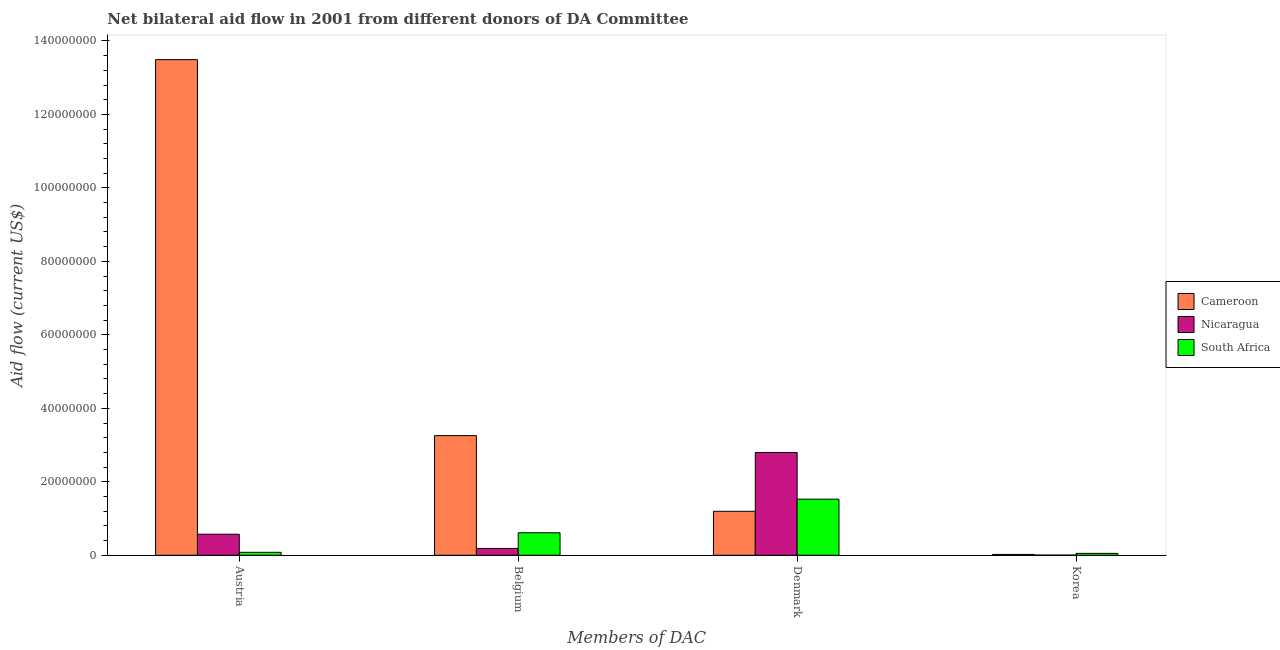How many groups of bars are there?
Make the answer very short. 4. Are the number of bars per tick equal to the number of legend labels?
Your response must be concise. Yes. How many bars are there on the 3rd tick from the left?
Offer a terse response. 3. What is the amount of aid given by austria in South Africa?
Keep it short and to the point. 8.00e+05. Across all countries, what is the maximum amount of aid given by korea?
Your answer should be compact. 5.10e+05. Across all countries, what is the minimum amount of aid given by korea?
Keep it short and to the point. 4.00e+04. In which country was the amount of aid given by korea maximum?
Provide a short and direct response. South Africa. In which country was the amount of aid given by austria minimum?
Make the answer very short. South Africa. What is the total amount of aid given by denmark in the graph?
Offer a very short reply. 5.52e+07. What is the difference between the amount of aid given by korea in Nicaragua and that in South Africa?
Ensure brevity in your answer.  -4.70e+05. What is the difference between the amount of aid given by korea in Nicaragua and the amount of aid given by austria in Cameroon?
Your response must be concise. -1.35e+08. What is the average amount of aid given by belgium per country?
Give a very brief answer. 1.35e+07. What is the difference between the amount of aid given by austria and amount of aid given by denmark in South Africa?
Make the answer very short. -1.45e+07. In how many countries, is the amount of aid given by austria greater than 40000000 US$?
Provide a short and direct response. 1. What is the ratio of the amount of aid given by korea in Cameroon to that in South Africa?
Keep it short and to the point. 0.45. Is the amount of aid given by belgium in South Africa less than that in Nicaragua?
Your response must be concise. No. What is the difference between the highest and the lowest amount of aid given by korea?
Your answer should be very brief. 4.70e+05. What does the 2nd bar from the left in Belgium represents?
Provide a short and direct response. Nicaragua. What does the 2nd bar from the right in Belgium represents?
Provide a succinct answer. Nicaragua. Is it the case that in every country, the sum of the amount of aid given by austria and amount of aid given by belgium is greater than the amount of aid given by denmark?
Make the answer very short. No. How many bars are there?
Your answer should be compact. 12. How many countries are there in the graph?
Your response must be concise. 3. What is the difference between two consecutive major ticks on the Y-axis?
Give a very brief answer. 2.00e+07. Does the graph contain any zero values?
Make the answer very short. No. What is the title of the graph?
Keep it short and to the point. Net bilateral aid flow in 2001 from different donors of DA Committee. Does "Brazil" appear as one of the legend labels in the graph?
Make the answer very short. No. What is the label or title of the X-axis?
Offer a very short reply. Members of DAC. What is the label or title of the Y-axis?
Offer a very short reply. Aid flow (current US$). What is the Aid flow (current US$) in Cameroon in Austria?
Your answer should be very brief. 1.35e+08. What is the Aid flow (current US$) in Nicaragua in Austria?
Provide a succinct answer. 5.73e+06. What is the Aid flow (current US$) in Cameroon in Belgium?
Ensure brevity in your answer.  3.26e+07. What is the Aid flow (current US$) in Nicaragua in Belgium?
Offer a terse response. 1.86e+06. What is the Aid flow (current US$) in South Africa in Belgium?
Offer a very short reply. 6.12e+06. What is the Aid flow (current US$) of Cameroon in Denmark?
Provide a succinct answer. 1.20e+07. What is the Aid flow (current US$) of Nicaragua in Denmark?
Ensure brevity in your answer.  2.80e+07. What is the Aid flow (current US$) in South Africa in Denmark?
Offer a very short reply. 1.53e+07. What is the Aid flow (current US$) of Cameroon in Korea?
Offer a very short reply. 2.30e+05. What is the Aid flow (current US$) of Nicaragua in Korea?
Give a very brief answer. 4.00e+04. What is the Aid flow (current US$) of South Africa in Korea?
Give a very brief answer. 5.10e+05. Across all Members of DAC, what is the maximum Aid flow (current US$) of Cameroon?
Provide a short and direct response. 1.35e+08. Across all Members of DAC, what is the maximum Aid flow (current US$) in Nicaragua?
Provide a succinct answer. 2.80e+07. Across all Members of DAC, what is the maximum Aid flow (current US$) of South Africa?
Your answer should be very brief. 1.53e+07. Across all Members of DAC, what is the minimum Aid flow (current US$) of Cameroon?
Your response must be concise. 2.30e+05. Across all Members of DAC, what is the minimum Aid flow (current US$) of South Africa?
Make the answer very short. 5.10e+05. What is the total Aid flow (current US$) of Cameroon in the graph?
Make the answer very short. 1.80e+08. What is the total Aid flow (current US$) of Nicaragua in the graph?
Keep it short and to the point. 3.56e+07. What is the total Aid flow (current US$) of South Africa in the graph?
Offer a very short reply. 2.27e+07. What is the difference between the Aid flow (current US$) in Cameroon in Austria and that in Belgium?
Give a very brief answer. 1.02e+08. What is the difference between the Aid flow (current US$) in Nicaragua in Austria and that in Belgium?
Provide a succinct answer. 3.87e+06. What is the difference between the Aid flow (current US$) in South Africa in Austria and that in Belgium?
Give a very brief answer. -5.32e+06. What is the difference between the Aid flow (current US$) in Cameroon in Austria and that in Denmark?
Provide a short and direct response. 1.23e+08. What is the difference between the Aid flow (current US$) in Nicaragua in Austria and that in Denmark?
Your answer should be compact. -2.22e+07. What is the difference between the Aid flow (current US$) of South Africa in Austria and that in Denmark?
Ensure brevity in your answer.  -1.45e+07. What is the difference between the Aid flow (current US$) in Cameroon in Austria and that in Korea?
Make the answer very short. 1.35e+08. What is the difference between the Aid flow (current US$) of Nicaragua in Austria and that in Korea?
Give a very brief answer. 5.69e+06. What is the difference between the Aid flow (current US$) of South Africa in Austria and that in Korea?
Make the answer very short. 2.90e+05. What is the difference between the Aid flow (current US$) of Cameroon in Belgium and that in Denmark?
Ensure brevity in your answer.  2.06e+07. What is the difference between the Aid flow (current US$) of Nicaragua in Belgium and that in Denmark?
Your answer should be compact. -2.61e+07. What is the difference between the Aid flow (current US$) in South Africa in Belgium and that in Denmark?
Your response must be concise. -9.15e+06. What is the difference between the Aid flow (current US$) in Cameroon in Belgium and that in Korea?
Your response must be concise. 3.23e+07. What is the difference between the Aid flow (current US$) in Nicaragua in Belgium and that in Korea?
Your answer should be very brief. 1.82e+06. What is the difference between the Aid flow (current US$) of South Africa in Belgium and that in Korea?
Your response must be concise. 5.61e+06. What is the difference between the Aid flow (current US$) of Cameroon in Denmark and that in Korea?
Your answer should be very brief. 1.17e+07. What is the difference between the Aid flow (current US$) of Nicaragua in Denmark and that in Korea?
Your answer should be very brief. 2.79e+07. What is the difference between the Aid flow (current US$) in South Africa in Denmark and that in Korea?
Provide a succinct answer. 1.48e+07. What is the difference between the Aid flow (current US$) in Cameroon in Austria and the Aid flow (current US$) in Nicaragua in Belgium?
Provide a succinct answer. 1.33e+08. What is the difference between the Aid flow (current US$) in Cameroon in Austria and the Aid flow (current US$) in South Africa in Belgium?
Your answer should be compact. 1.29e+08. What is the difference between the Aid flow (current US$) in Nicaragua in Austria and the Aid flow (current US$) in South Africa in Belgium?
Your answer should be very brief. -3.90e+05. What is the difference between the Aid flow (current US$) in Cameroon in Austria and the Aid flow (current US$) in Nicaragua in Denmark?
Offer a terse response. 1.07e+08. What is the difference between the Aid flow (current US$) in Cameroon in Austria and the Aid flow (current US$) in South Africa in Denmark?
Provide a short and direct response. 1.20e+08. What is the difference between the Aid flow (current US$) in Nicaragua in Austria and the Aid flow (current US$) in South Africa in Denmark?
Make the answer very short. -9.54e+06. What is the difference between the Aid flow (current US$) of Cameroon in Austria and the Aid flow (current US$) of Nicaragua in Korea?
Keep it short and to the point. 1.35e+08. What is the difference between the Aid flow (current US$) of Cameroon in Austria and the Aid flow (current US$) of South Africa in Korea?
Provide a succinct answer. 1.34e+08. What is the difference between the Aid flow (current US$) of Nicaragua in Austria and the Aid flow (current US$) of South Africa in Korea?
Your answer should be very brief. 5.22e+06. What is the difference between the Aid flow (current US$) in Cameroon in Belgium and the Aid flow (current US$) in Nicaragua in Denmark?
Provide a short and direct response. 4.60e+06. What is the difference between the Aid flow (current US$) in Cameroon in Belgium and the Aid flow (current US$) in South Africa in Denmark?
Your answer should be very brief. 1.73e+07. What is the difference between the Aid flow (current US$) in Nicaragua in Belgium and the Aid flow (current US$) in South Africa in Denmark?
Give a very brief answer. -1.34e+07. What is the difference between the Aid flow (current US$) in Cameroon in Belgium and the Aid flow (current US$) in Nicaragua in Korea?
Your answer should be very brief. 3.25e+07. What is the difference between the Aid flow (current US$) in Cameroon in Belgium and the Aid flow (current US$) in South Africa in Korea?
Keep it short and to the point. 3.21e+07. What is the difference between the Aid flow (current US$) of Nicaragua in Belgium and the Aid flow (current US$) of South Africa in Korea?
Provide a short and direct response. 1.35e+06. What is the difference between the Aid flow (current US$) of Cameroon in Denmark and the Aid flow (current US$) of Nicaragua in Korea?
Your answer should be compact. 1.19e+07. What is the difference between the Aid flow (current US$) of Cameroon in Denmark and the Aid flow (current US$) of South Africa in Korea?
Your response must be concise. 1.15e+07. What is the difference between the Aid flow (current US$) in Nicaragua in Denmark and the Aid flow (current US$) in South Africa in Korea?
Offer a terse response. 2.75e+07. What is the average Aid flow (current US$) in Cameroon per Members of DAC?
Provide a short and direct response. 4.49e+07. What is the average Aid flow (current US$) of Nicaragua per Members of DAC?
Keep it short and to the point. 8.90e+06. What is the average Aid flow (current US$) of South Africa per Members of DAC?
Make the answer very short. 5.68e+06. What is the difference between the Aid flow (current US$) in Cameroon and Aid flow (current US$) in Nicaragua in Austria?
Make the answer very short. 1.29e+08. What is the difference between the Aid flow (current US$) of Cameroon and Aid flow (current US$) of South Africa in Austria?
Offer a terse response. 1.34e+08. What is the difference between the Aid flow (current US$) in Nicaragua and Aid flow (current US$) in South Africa in Austria?
Your answer should be compact. 4.93e+06. What is the difference between the Aid flow (current US$) of Cameroon and Aid flow (current US$) of Nicaragua in Belgium?
Keep it short and to the point. 3.07e+07. What is the difference between the Aid flow (current US$) of Cameroon and Aid flow (current US$) of South Africa in Belgium?
Offer a terse response. 2.64e+07. What is the difference between the Aid flow (current US$) in Nicaragua and Aid flow (current US$) in South Africa in Belgium?
Give a very brief answer. -4.26e+06. What is the difference between the Aid flow (current US$) in Cameroon and Aid flow (current US$) in Nicaragua in Denmark?
Your answer should be compact. -1.60e+07. What is the difference between the Aid flow (current US$) in Cameroon and Aid flow (current US$) in South Africa in Denmark?
Make the answer very short. -3.30e+06. What is the difference between the Aid flow (current US$) in Nicaragua and Aid flow (current US$) in South Africa in Denmark?
Ensure brevity in your answer.  1.27e+07. What is the difference between the Aid flow (current US$) in Cameroon and Aid flow (current US$) in South Africa in Korea?
Provide a short and direct response. -2.80e+05. What is the difference between the Aid flow (current US$) of Nicaragua and Aid flow (current US$) of South Africa in Korea?
Ensure brevity in your answer.  -4.70e+05. What is the ratio of the Aid flow (current US$) in Cameroon in Austria to that in Belgium?
Offer a terse response. 4.14. What is the ratio of the Aid flow (current US$) of Nicaragua in Austria to that in Belgium?
Offer a very short reply. 3.08. What is the ratio of the Aid flow (current US$) in South Africa in Austria to that in Belgium?
Provide a succinct answer. 0.13. What is the ratio of the Aid flow (current US$) in Cameroon in Austria to that in Denmark?
Provide a succinct answer. 11.27. What is the ratio of the Aid flow (current US$) of Nicaragua in Austria to that in Denmark?
Offer a terse response. 0.2. What is the ratio of the Aid flow (current US$) of South Africa in Austria to that in Denmark?
Provide a succinct answer. 0.05. What is the ratio of the Aid flow (current US$) in Cameroon in Austria to that in Korea?
Your answer should be very brief. 586.57. What is the ratio of the Aid flow (current US$) of Nicaragua in Austria to that in Korea?
Provide a short and direct response. 143.25. What is the ratio of the Aid flow (current US$) of South Africa in Austria to that in Korea?
Give a very brief answer. 1.57. What is the ratio of the Aid flow (current US$) in Cameroon in Belgium to that in Denmark?
Your response must be concise. 2.72. What is the ratio of the Aid flow (current US$) of Nicaragua in Belgium to that in Denmark?
Keep it short and to the point. 0.07. What is the ratio of the Aid flow (current US$) in South Africa in Belgium to that in Denmark?
Your answer should be compact. 0.4. What is the ratio of the Aid flow (current US$) in Cameroon in Belgium to that in Korea?
Provide a short and direct response. 141.61. What is the ratio of the Aid flow (current US$) of Nicaragua in Belgium to that in Korea?
Ensure brevity in your answer.  46.5. What is the ratio of the Aid flow (current US$) of Cameroon in Denmark to that in Korea?
Keep it short and to the point. 52.04. What is the ratio of the Aid flow (current US$) in Nicaragua in Denmark to that in Korea?
Offer a very short reply. 699.25. What is the ratio of the Aid flow (current US$) of South Africa in Denmark to that in Korea?
Make the answer very short. 29.94. What is the difference between the highest and the second highest Aid flow (current US$) in Cameroon?
Make the answer very short. 1.02e+08. What is the difference between the highest and the second highest Aid flow (current US$) of Nicaragua?
Offer a very short reply. 2.22e+07. What is the difference between the highest and the second highest Aid flow (current US$) in South Africa?
Provide a succinct answer. 9.15e+06. What is the difference between the highest and the lowest Aid flow (current US$) of Cameroon?
Your response must be concise. 1.35e+08. What is the difference between the highest and the lowest Aid flow (current US$) of Nicaragua?
Offer a very short reply. 2.79e+07. What is the difference between the highest and the lowest Aid flow (current US$) in South Africa?
Your answer should be very brief. 1.48e+07. 